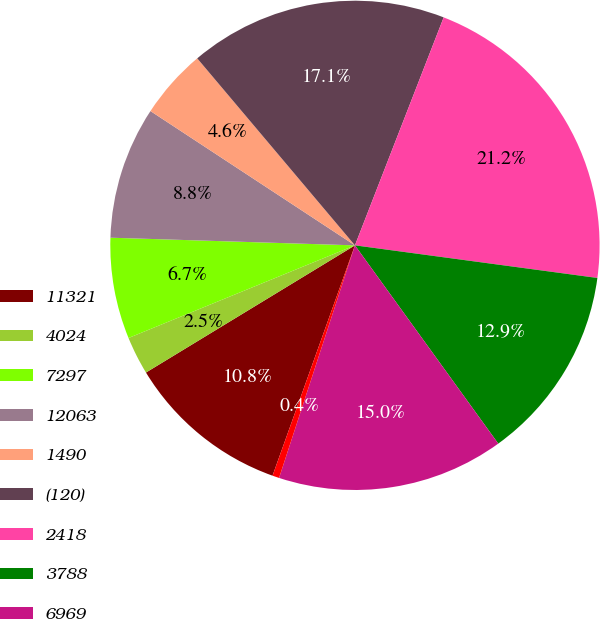Convert chart. <chart><loc_0><loc_0><loc_500><loc_500><pie_chart><fcel>11321<fcel>4024<fcel>7297<fcel>12063<fcel>1490<fcel>(120)<fcel>2418<fcel>3788<fcel>6969<fcel>58<nl><fcel>10.83%<fcel>2.52%<fcel>6.68%<fcel>8.75%<fcel>4.6%<fcel>17.06%<fcel>21.22%<fcel>12.91%<fcel>14.98%<fcel>0.45%<nl></chart> 